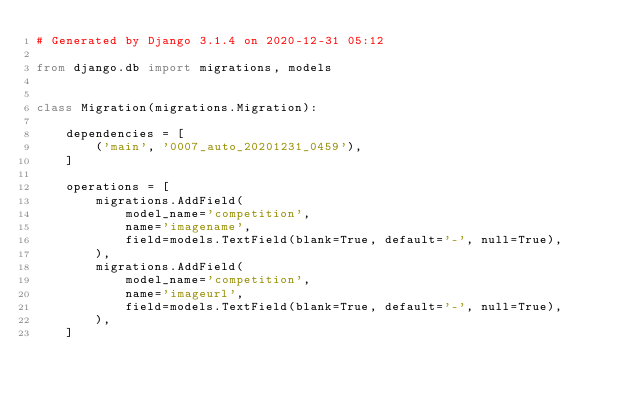<code> <loc_0><loc_0><loc_500><loc_500><_Python_># Generated by Django 3.1.4 on 2020-12-31 05:12

from django.db import migrations, models


class Migration(migrations.Migration):

    dependencies = [
        ('main', '0007_auto_20201231_0459'),
    ]

    operations = [
        migrations.AddField(
            model_name='competition',
            name='imagename',
            field=models.TextField(blank=True, default='-', null=True),
        ),
        migrations.AddField(
            model_name='competition',
            name='imageurl',
            field=models.TextField(blank=True, default='-', null=True),
        ),
    ]
</code> 